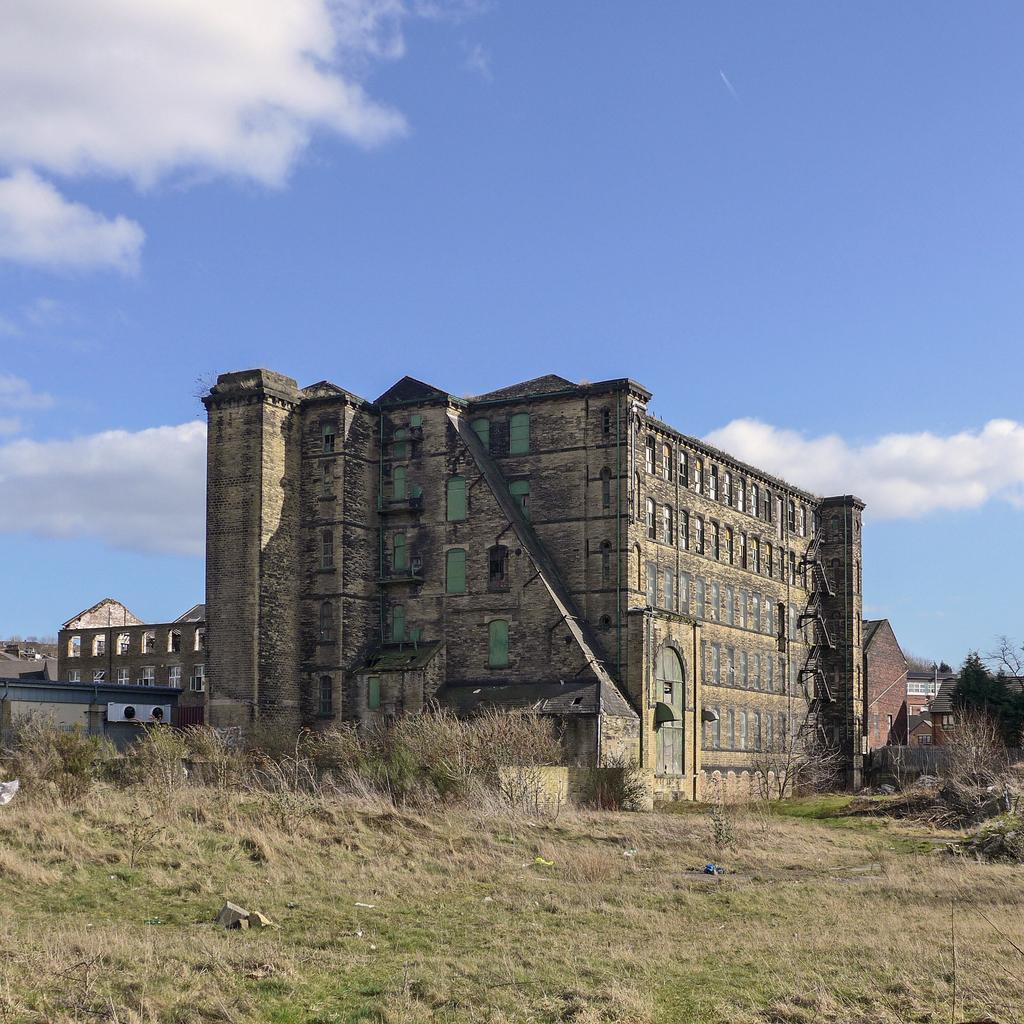In one or two sentences, can you explain what this image depicts? This image is clicked outside. There are bushes in the middle. There is grass at the bottom. There is a building in the middle. It has windows. There is sky at the top. There are trees on the right side. 